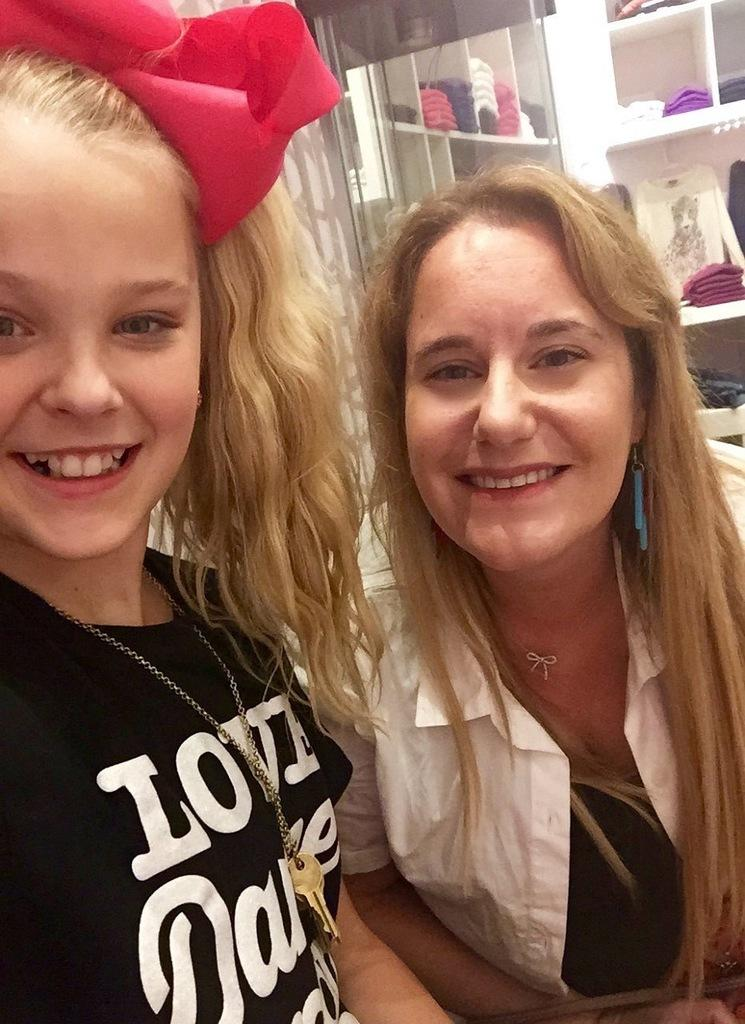How many people are in the image? There are two persons in the image. Can you describe the appearance of the girl in the image? The girl is wearing a black dress. What is the woman in the image wearing? The woman is wearing a white shirt. What can be seen in the background of the image? There is a group of clothes placed in racks in the background of the image. What type of building can be seen in the image? There is no building present in the image; it features two persons and a group of clothes placed in racks in the background. 